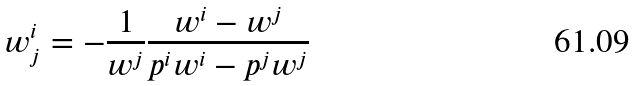Convert formula to latex. <formula><loc_0><loc_0><loc_500><loc_500>w ^ { i } _ { j } = - \frac { 1 } { w ^ { j } } \frac { w ^ { i } - w ^ { j } } { p ^ { i } w ^ { i } - p ^ { j } w ^ { j } }</formula> 